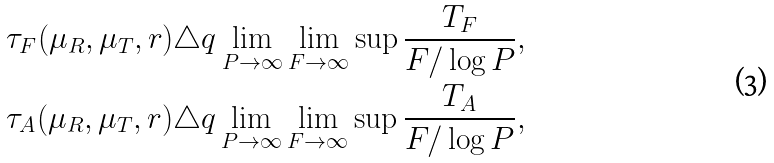Convert formula to latex. <formula><loc_0><loc_0><loc_500><loc_500>& \tau _ { F } ( \mu _ { R } , \mu _ { T } , r ) \triangle q \lim _ { P \to \infty } \lim _ { F \to \infty } \sup \frac { T _ { F } } { F / \log P } , \\ & \tau _ { A } ( \mu _ { R } , \mu _ { T } , r ) \triangle q \lim _ { P \to \infty } \lim _ { F \to \infty } \sup \frac { T _ { A } } { F / \log P } ,</formula> 